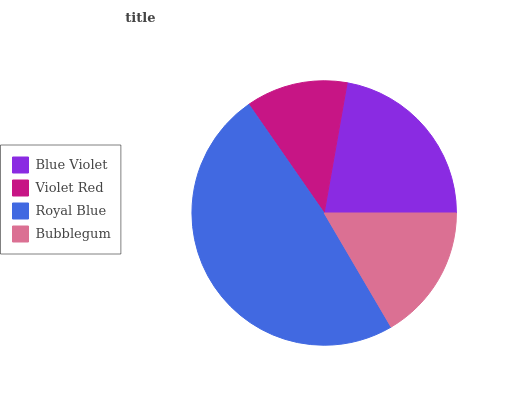Is Violet Red the minimum?
Answer yes or no. Yes. Is Royal Blue the maximum?
Answer yes or no. Yes. Is Royal Blue the minimum?
Answer yes or no. No. Is Violet Red the maximum?
Answer yes or no. No. Is Royal Blue greater than Violet Red?
Answer yes or no. Yes. Is Violet Red less than Royal Blue?
Answer yes or no. Yes. Is Violet Red greater than Royal Blue?
Answer yes or no. No. Is Royal Blue less than Violet Red?
Answer yes or no. No. Is Blue Violet the high median?
Answer yes or no. Yes. Is Bubblegum the low median?
Answer yes or no. Yes. Is Bubblegum the high median?
Answer yes or no. No. Is Violet Red the low median?
Answer yes or no. No. 